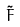Convert formula to latex. <formula><loc_0><loc_0><loc_500><loc_500>\tilde { F }</formula> 